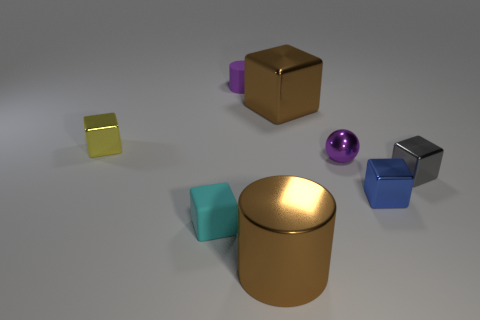Subtract all tiny cyan blocks. How many blocks are left? 4 Subtract all purple cylinders. How many cylinders are left? 1 Subtract all balls. How many objects are left? 7 Add 1 cyan cylinders. How many objects exist? 9 Subtract 1 cyan blocks. How many objects are left? 7 Subtract all gray spheres. Subtract all green cubes. How many spheres are left? 1 Subtract all tiny rubber things. Subtract all gray objects. How many objects are left? 5 Add 4 large brown cylinders. How many large brown cylinders are left? 5 Add 7 small matte cylinders. How many small matte cylinders exist? 8 